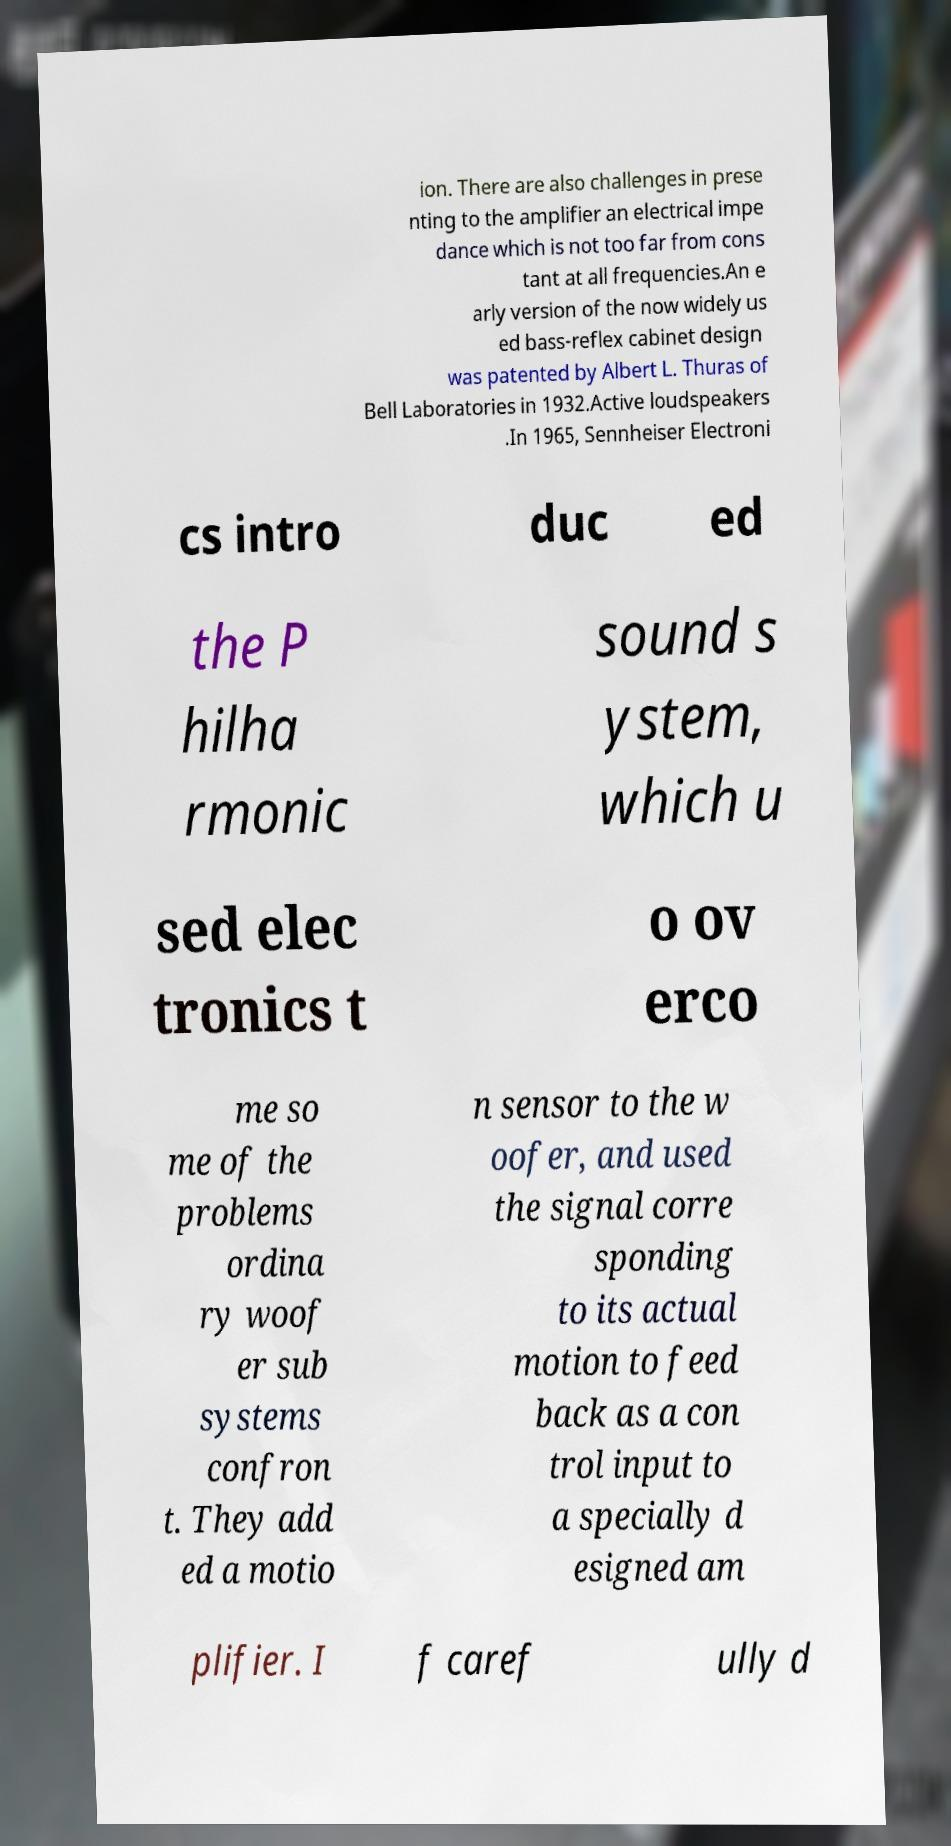For documentation purposes, I need the text within this image transcribed. Could you provide that? ion. There are also challenges in prese nting to the amplifier an electrical impe dance which is not too far from cons tant at all frequencies.An e arly version of the now widely us ed bass-reflex cabinet design was patented by Albert L. Thuras of Bell Laboratories in 1932.Active loudspeakers .In 1965, Sennheiser Electroni cs intro duc ed the P hilha rmonic sound s ystem, which u sed elec tronics t o ov erco me so me of the problems ordina ry woof er sub systems confron t. They add ed a motio n sensor to the w oofer, and used the signal corre sponding to its actual motion to feed back as a con trol input to a specially d esigned am plifier. I f caref ully d 